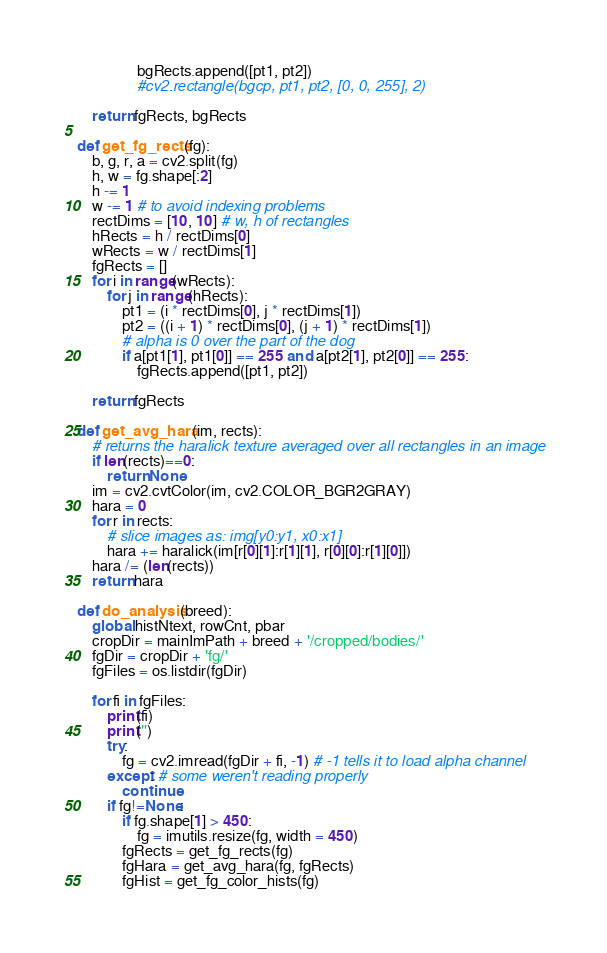Convert code to text. <code><loc_0><loc_0><loc_500><loc_500><_Python_>                bgRects.append([pt1, pt2])
                #cv2.rectangle(bgcp, pt1, pt2, [0, 0, 255], 2)
    
    return fgRects, bgRects

def get_fg_rects(fg):
    b, g, r, a = cv2.split(fg)
    h, w = fg.shape[:2]
    h -= 1
    w -= 1 # to avoid indexing problems
    rectDims = [10, 10] # w, h of rectangles
    hRects = h / rectDims[0]
    wRects = w / rectDims[1]
    fgRects = []
    for i in range(wRects):
        for j in range(hRects):
            pt1 = (i * rectDims[0], j * rectDims[1])
            pt2 = ((i + 1) * rectDims[0], (j + 1) * rectDims[1])
            # alpha is 0 over the part of the dog
            if a[pt1[1], pt1[0]] == 255 and a[pt2[1], pt2[0]] == 255:
                fgRects.append([pt1, pt2])
    
    return fgRects

def get_avg_hara(im, rects):
    # returns the haralick texture averaged over all rectangles in an image
    if len(rects)==0:
        return None
    im = cv2.cvtColor(im, cv2.COLOR_BGR2GRAY)
    hara = 0
    for r in rects:
        # slice images as: img[y0:y1, x0:x1]
        hara += haralick(im[r[0][1]:r[1][1], r[0][0]:r[1][0]])
    hara /= (len(rects))
    return hara

def do_analysis(breed):
    global histNtext, rowCnt, pbar
    cropDir = mainImPath + breed + '/cropped/bodies/'
    fgDir = cropDir + 'fg/'
    fgFiles = os.listdir(fgDir)

    for fi in fgFiles:
        print(fi)
        print('')
        try:
            fg = cv2.imread(fgDir + fi, -1) # -1 tells it to load alpha channel
        except: # some weren't reading properly
            continue
        if fg!=None:
            if fg.shape[1] > 450:
                fg = imutils.resize(fg, width = 450)
            fgRects = get_fg_rects(fg)
            fgHara = get_avg_hara(fg, fgRects)
            fgHist = get_fg_color_hists(fg)</code> 